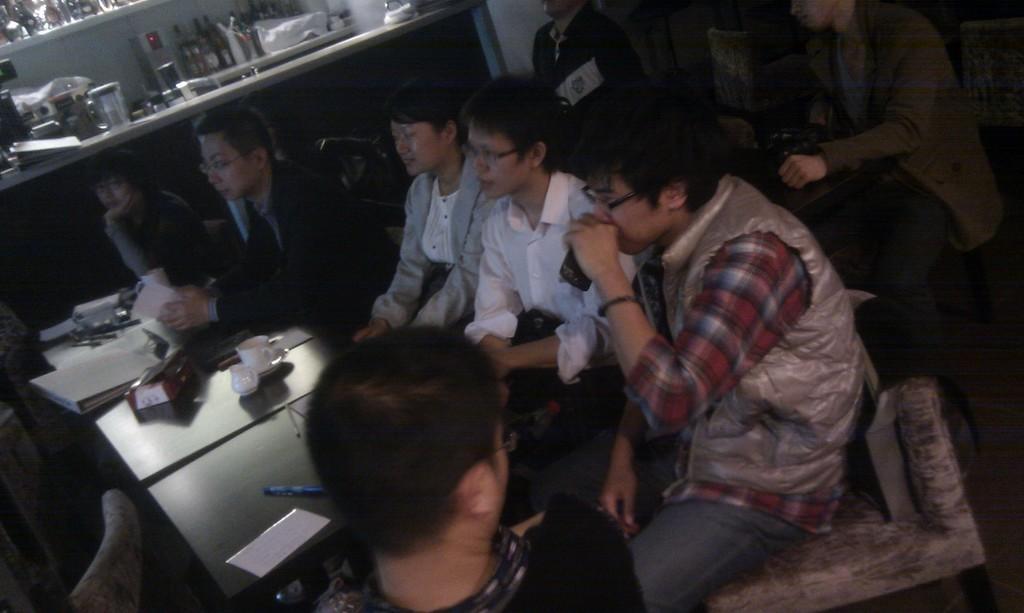Could you give a brief overview of what you see in this image? In this picture there are few persons sitting and there is a table in front of them which has some objects on it and there are few other people behind them. 